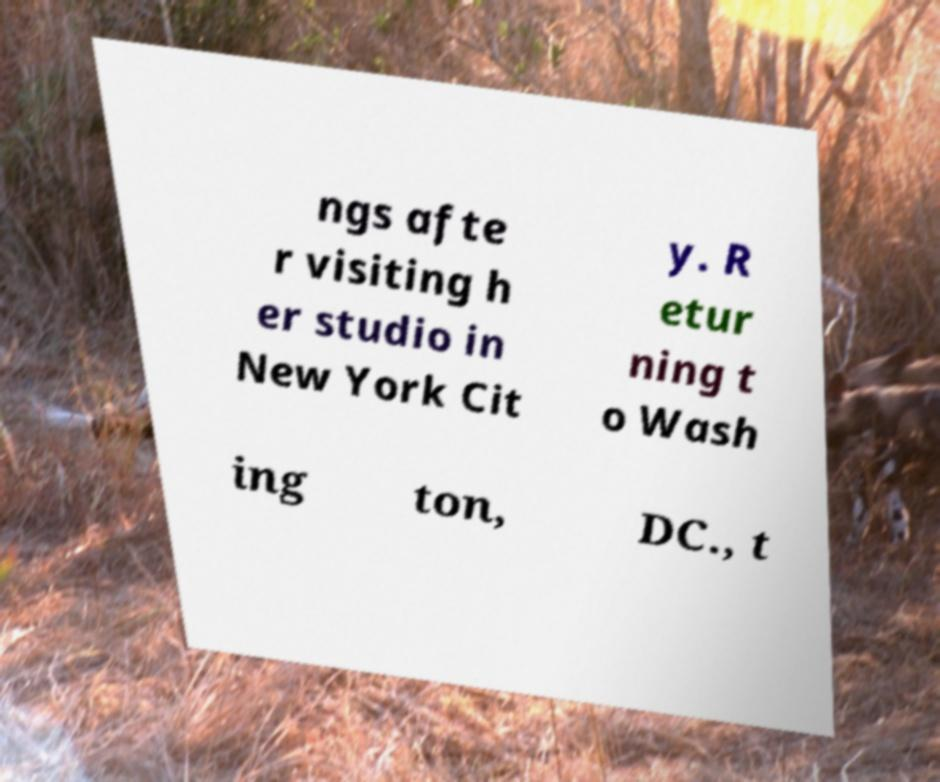What messages or text are displayed in this image? I need them in a readable, typed format. ngs afte r visiting h er studio in New York Cit y. R etur ning t o Wash ing ton, DC., t 